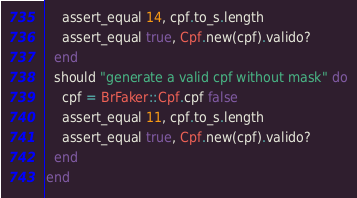Convert code to text. <code><loc_0><loc_0><loc_500><loc_500><_Ruby_>    assert_equal 14, cpf.to_s.length
    assert_equal true, Cpf.new(cpf).valido?
  end
  should "generate a valid cpf without mask" do
    cpf = BrFaker::Cpf.cpf false  
    assert_equal 11, cpf.to_s.length
    assert_equal true, Cpf.new(cpf).valido?
  end
end</code> 